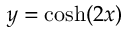Convert formula to latex. <formula><loc_0><loc_0><loc_500><loc_500>y = \cosh ( 2 x )</formula> 